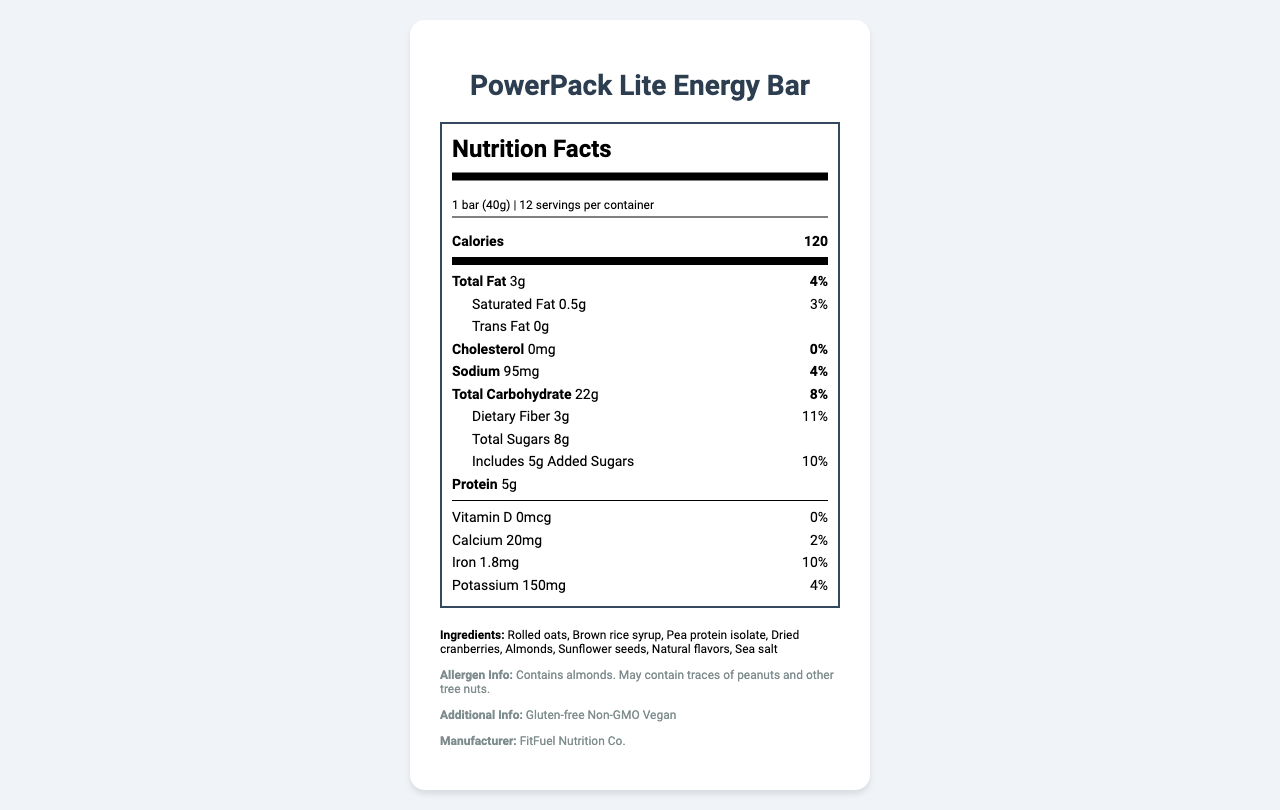what is the serving size? The serving size is directly stated under the "serving_info" section of the Nutrition Facts Label.
Answer: 1 bar (40g) what is the calorie content per serving? The calorie content is listed at the top of the Nutrition Facts Label next to the heading "Calories."
Answer: 120 how much dietary fiber is in one bar? The amount of dietary fiber is mentioned under the "total_carbohydrate" section as "Dietary Fiber."
Answer: 3g what is the percentage daily value of iron in one serving? The percentage daily value of iron is listed in the "nutrient" section towards the bottom of the Nutrition Facts Label.
Answer: 10% are there any vitamins in the PowerPack Lite Energy Bar? The Nutrition Facts Label lists Vitamin D with an amount of 0mcg and a daily value of 0%.
Answer: Yes, there is Vitamin D. how many grams of protein does the bar contain? The amount of protein is provided under the "protein" section of the Nutrition Facts Label.
Answer: 5g which of the following ingredients is NOT listed in the PowerPack Lite Energy Bar?
A. Almonds
B. Brown rice syrup
C. Whey protein
D. Dried cranberries Whey protein is not listed in the "ingredients" section; the list includes almonds, brown rice syrup, dried cranberries, among other ingredients.
Answer: C what is the total amount of sugars in one bar? A. 5g B. 8g C. 3g D. 10g According to the "total_sugars" section, the bar contains 8 grams of total sugars.
Answer: B does this product contain gluten? The "additional_info" section indicates that the product is gluten-free.
Answer: No is this energy bar suitable for vegans? The "additional_info" section states that the product is vegan.
Answer: Yes summarize the main details of this energy bar. The document provides a comprehensive overview of the PowerPack Lite Energy Bar, including its serving size, nutritional content, ingredients, allergen information, and manufacturer details. The product is highlighted as an ideal low-calorie, nutrient-dense snack suitable for busy entrepreneurs.
Answer: The PowerPack Lite Energy Bar is a low-calorie, vegan, gluten-free, and non-GMO energy bar. Each 40g serving contains 120 calories, 3g of total fat, 22g of carbohydrates (including 3g of dietary fiber and 8g of sugars), and 5g of protein. It includes ingredients like rolled oats, brown rice syrup, pea protein isolate, and dried cranberries, and is produced by FitFuel Nutrition Co. what are the main allergens in this bar? The allergen information section states that the product contains almonds and may contain traces of peanuts and other tree nuts.
Answer: Almonds how many servings are there in one container? The number of servings per container is listed at the top of the Nutrition Facts Label as 12.
Answer: 12 what is the manufacturer of the PowerPack Lite Energy Bar? The manufacturer is mentioned in the "additional_info" section as FitFuel Nutrition Co.
Answer: FitFuel Nutrition Co. are there any trans fats in this energy bar? The amount of trans fat is listed as 0g in the Nutrition Facts Label.
Answer: No how long has the PowerPack Lite Energy Bar been on the market? The document does not provide any information on how long the product has been available.
Answer: Not enough information 